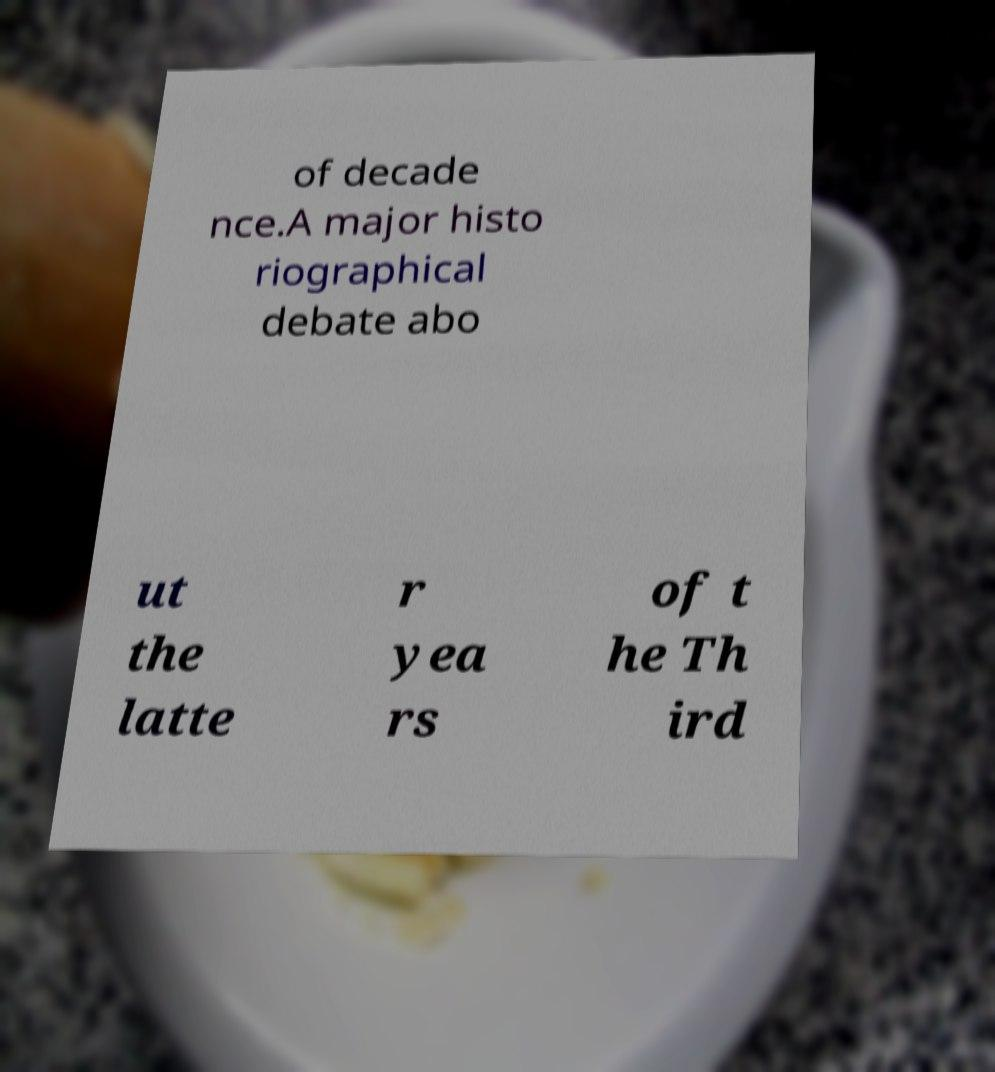Please read and relay the text visible in this image. What does it say? of decade nce.A major histo riographical debate abo ut the latte r yea rs of t he Th ird 